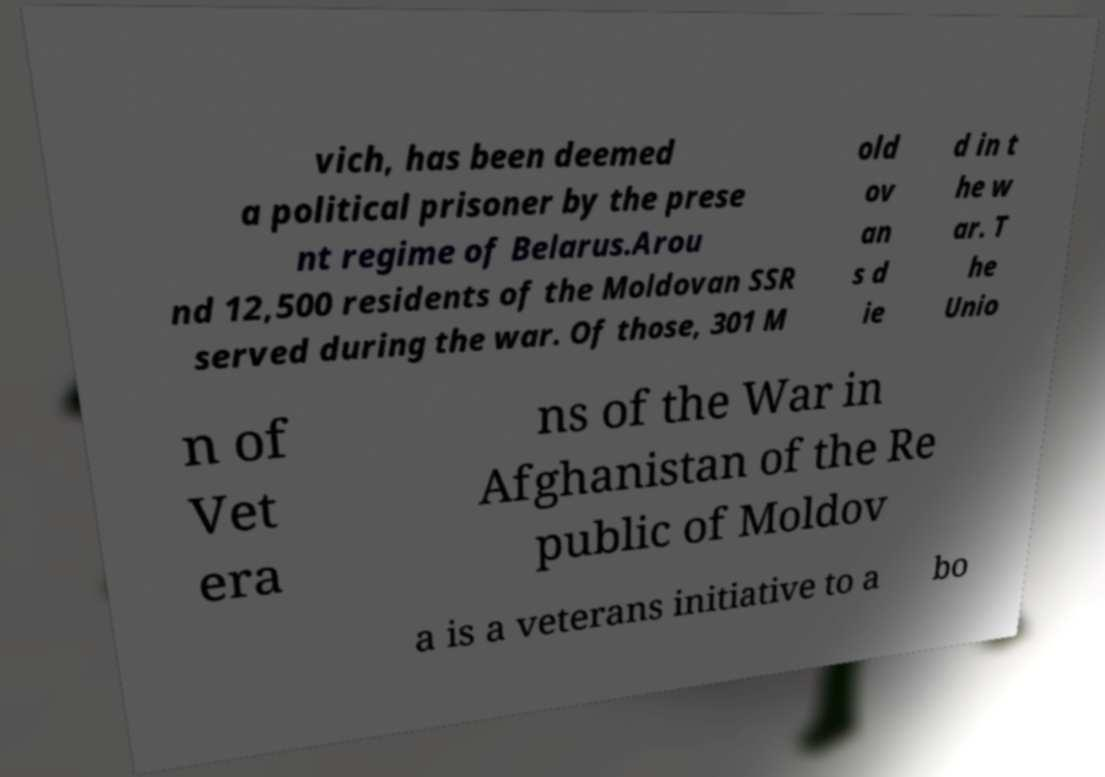Can you read and provide the text displayed in the image?This photo seems to have some interesting text. Can you extract and type it out for me? vich, has been deemed a political prisoner by the prese nt regime of Belarus.Arou nd 12,500 residents of the Moldovan SSR served during the war. Of those, 301 M old ov an s d ie d in t he w ar. T he Unio n of Vet era ns of the War in Afghanistan of the Re public of Moldov a is a veterans initiative to a bo 